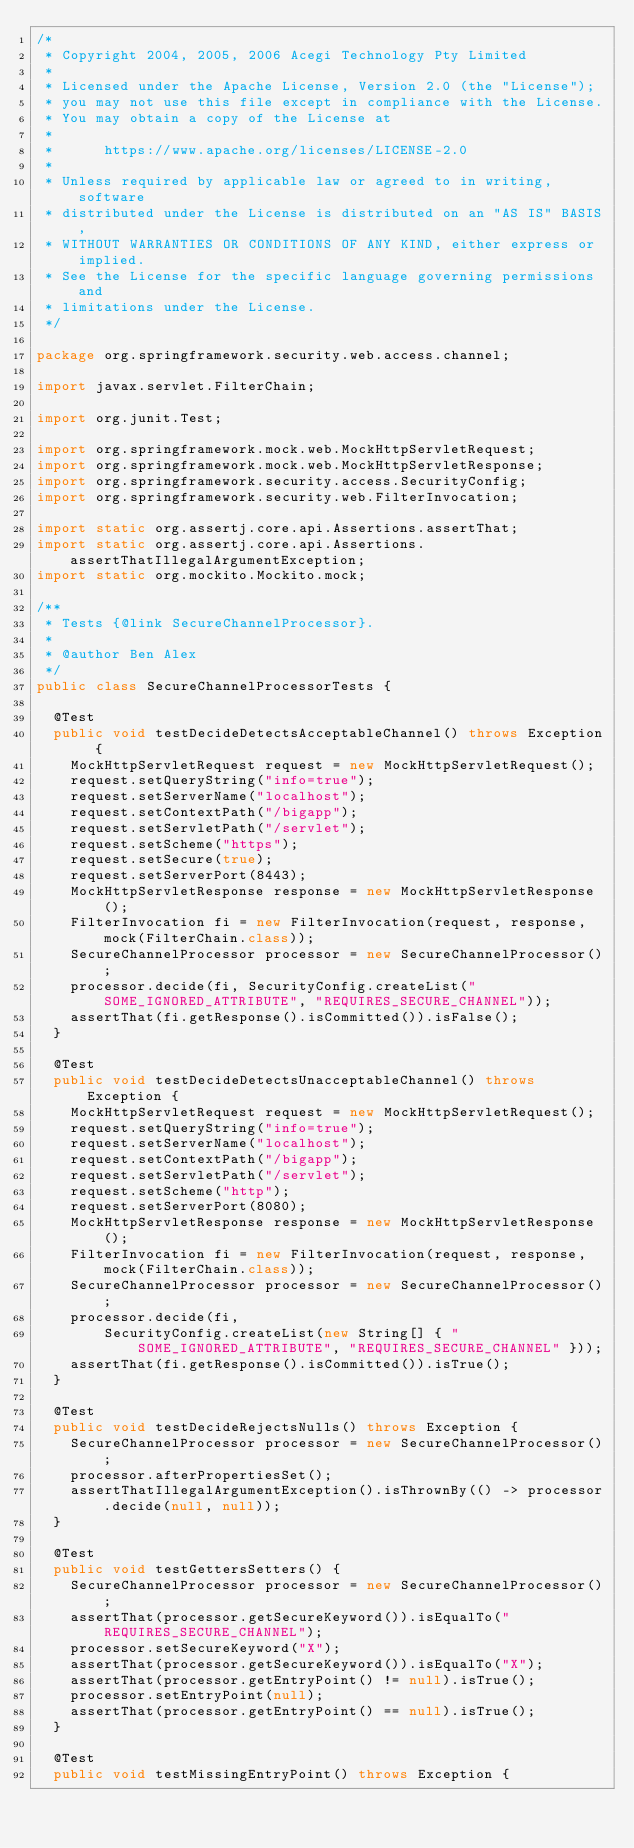<code> <loc_0><loc_0><loc_500><loc_500><_Java_>/*
 * Copyright 2004, 2005, 2006 Acegi Technology Pty Limited
 *
 * Licensed under the Apache License, Version 2.0 (the "License");
 * you may not use this file except in compliance with the License.
 * You may obtain a copy of the License at
 *
 *      https://www.apache.org/licenses/LICENSE-2.0
 *
 * Unless required by applicable law or agreed to in writing, software
 * distributed under the License is distributed on an "AS IS" BASIS,
 * WITHOUT WARRANTIES OR CONDITIONS OF ANY KIND, either express or implied.
 * See the License for the specific language governing permissions and
 * limitations under the License.
 */

package org.springframework.security.web.access.channel;

import javax.servlet.FilterChain;

import org.junit.Test;

import org.springframework.mock.web.MockHttpServletRequest;
import org.springframework.mock.web.MockHttpServletResponse;
import org.springframework.security.access.SecurityConfig;
import org.springframework.security.web.FilterInvocation;

import static org.assertj.core.api.Assertions.assertThat;
import static org.assertj.core.api.Assertions.assertThatIllegalArgumentException;
import static org.mockito.Mockito.mock;

/**
 * Tests {@link SecureChannelProcessor}.
 *
 * @author Ben Alex
 */
public class SecureChannelProcessorTests {

	@Test
	public void testDecideDetectsAcceptableChannel() throws Exception {
		MockHttpServletRequest request = new MockHttpServletRequest();
		request.setQueryString("info=true");
		request.setServerName("localhost");
		request.setContextPath("/bigapp");
		request.setServletPath("/servlet");
		request.setScheme("https");
		request.setSecure(true);
		request.setServerPort(8443);
		MockHttpServletResponse response = new MockHttpServletResponse();
		FilterInvocation fi = new FilterInvocation(request, response, mock(FilterChain.class));
		SecureChannelProcessor processor = new SecureChannelProcessor();
		processor.decide(fi, SecurityConfig.createList("SOME_IGNORED_ATTRIBUTE", "REQUIRES_SECURE_CHANNEL"));
		assertThat(fi.getResponse().isCommitted()).isFalse();
	}

	@Test
	public void testDecideDetectsUnacceptableChannel() throws Exception {
		MockHttpServletRequest request = new MockHttpServletRequest();
		request.setQueryString("info=true");
		request.setServerName("localhost");
		request.setContextPath("/bigapp");
		request.setServletPath("/servlet");
		request.setScheme("http");
		request.setServerPort(8080);
		MockHttpServletResponse response = new MockHttpServletResponse();
		FilterInvocation fi = new FilterInvocation(request, response, mock(FilterChain.class));
		SecureChannelProcessor processor = new SecureChannelProcessor();
		processor.decide(fi,
				SecurityConfig.createList(new String[] { "SOME_IGNORED_ATTRIBUTE", "REQUIRES_SECURE_CHANNEL" }));
		assertThat(fi.getResponse().isCommitted()).isTrue();
	}

	@Test
	public void testDecideRejectsNulls() throws Exception {
		SecureChannelProcessor processor = new SecureChannelProcessor();
		processor.afterPropertiesSet();
		assertThatIllegalArgumentException().isThrownBy(() -> processor.decide(null, null));
	}

	@Test
	public void testGettersSetters() {
		SecureChannelProcessor processor = new SecureChannelProcessor();
		assertThat(processor.getSecureKeyword()).isEqualTo("REQUIRES_SECURE_CHANNEL");
		processor.setSecureKeyword("X");
		assertThat(processor.getSecureKeyword()).isEqualTo("X");
		assertThat(processor.getEntryPoint() != null).isTrue();
		processor.setEntryPoint(null);
		assertThat(processor.getEntryPoint() == null).isTrue();
	}

	@Test
	public void testMissingEntryPoint() throws Exception {</code> 